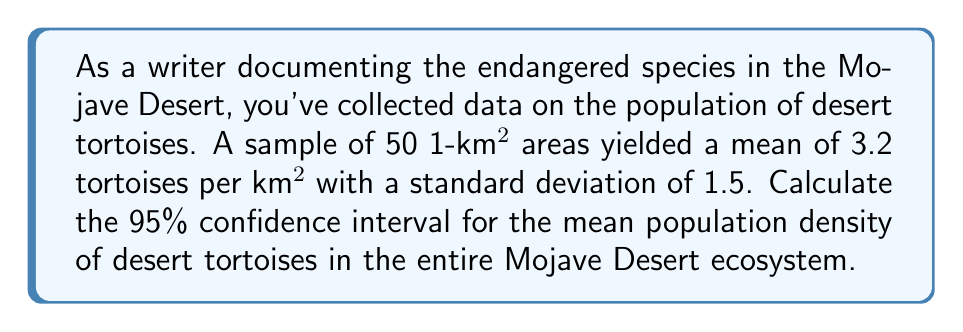Can you solve this math problem? To calculate the confidence interval, we'll follow these steps:

1. Identify the known values:
   - Sample size: $n = 50$
   - Sample mean: $\bar{x} = 3.2$ tortoises per km²
   - Sample standard deviation: $s = 1.5$ tortoises per km²
   - Confidence level: 95% (α = 0.05)

2. Determine the critical value:
   For a 95% confidence interval with 49 degrees of freedom (n-1), we use the t-distribution. The critical value is approximately $t_{0.025, 49} = 2.009$ (from t-table or calculator).

3. Calculate the margin of error:
   Margin of Error = $t_{0.025, 49} \cdot \frac{s}{\sqrt{n}}$
   $$ \text{ME} = 2.009 \cdot \frac{1.5}{\sqrt{50}} = 0.4268 $$

4. Compute the confidence interval:
   Lower bound: $\bar{x} - \text{ME} = 3.2 - 0.4268 = 2.7732$
   Upper bound: $\bar{x} + \text{ME} = 3.2 + 0.4268 = 3.6268$

Therefore, we can be 95% confident that the true mean population density of desert tortoises in the Mojave Desert ecosystem is between 2.7732 and 3.6268 tortoises per km².
Answer: (2.7732, 3.6268) tortoises per km² 